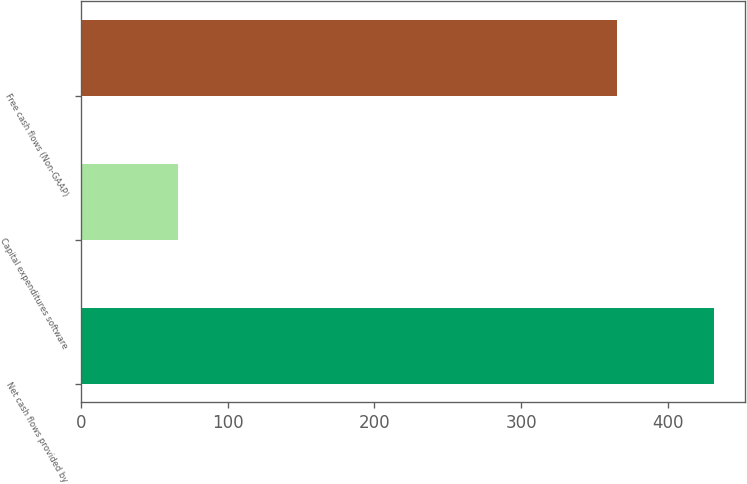Convert chart. <chart><loc_0><loc_0><loc_500><loc_500><bar_chart><fcel>Net cash flows provided by<fcel>Capital expenditures software<fcel>Free cash flows (Non-GAAP)<nl><fcel>431.4<fcel>66<fcel>365.4<nl></chart> 